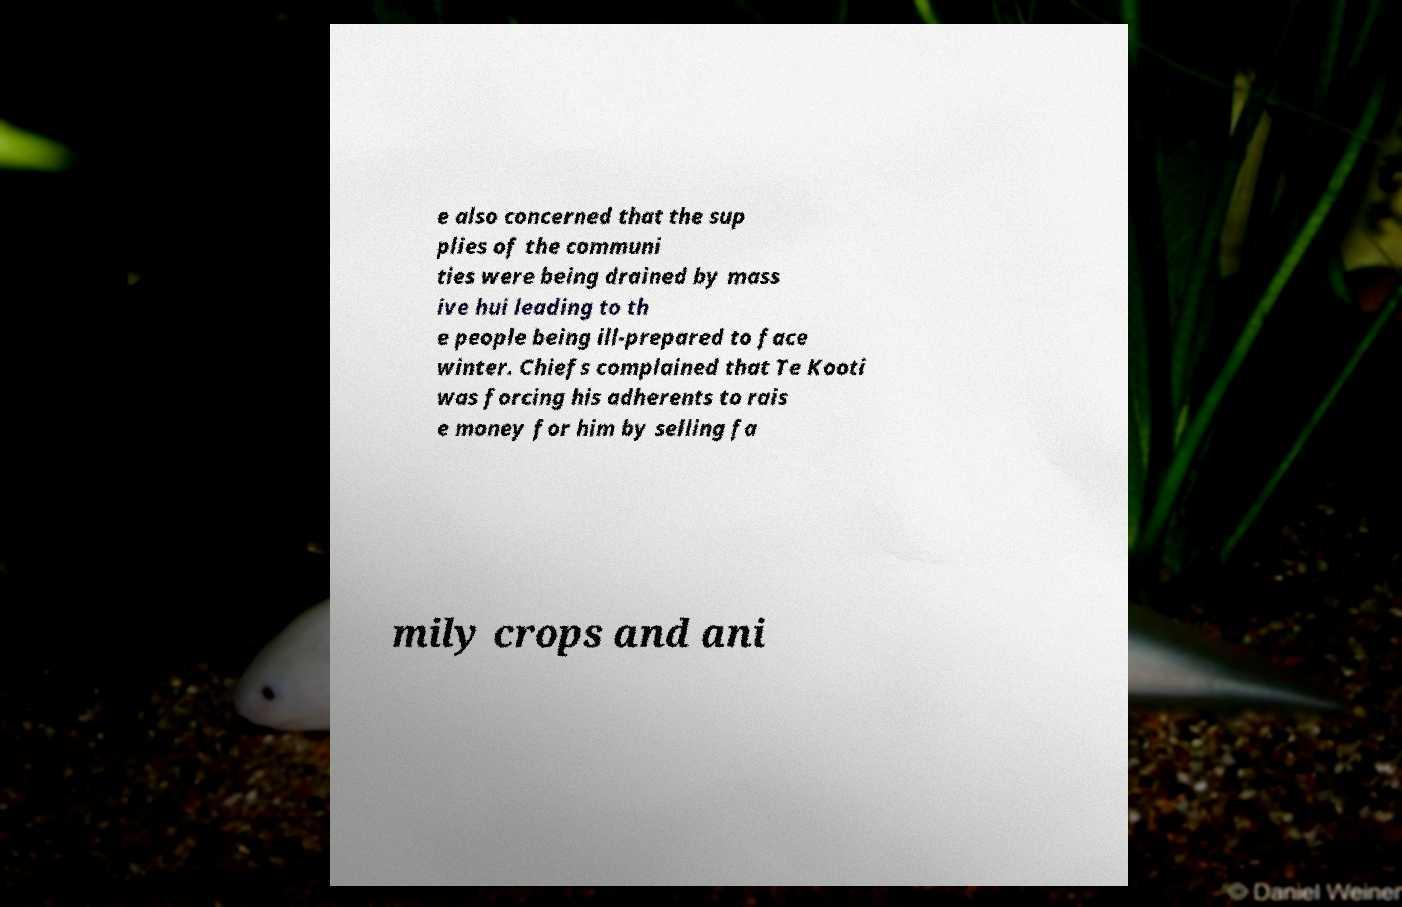I need the written content from this picture converted into text. Can you do that? e also concerned that the sup plies of the communi ties were being drained by mass ive hui leading to th e people being ill-prepared to face winter. Chiefs complained that Te Kooti was forcing his adherents to rais e money for him by selling fa mily crops and ani 